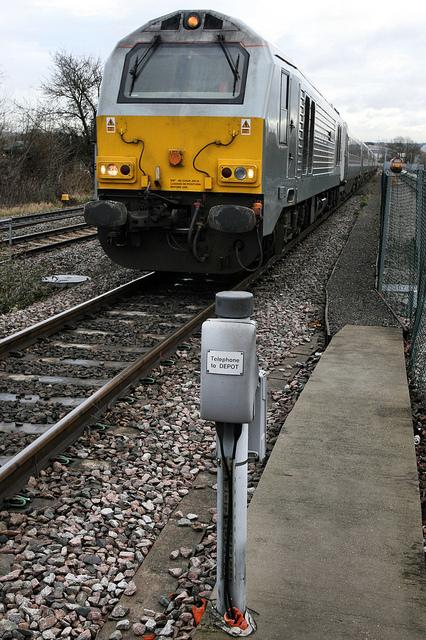What color is the train?
Be succinct. Yellow. What mode of transportation is this?
Concise answer only. Train. Does the train have lights?
Quick response, please. Yes. 